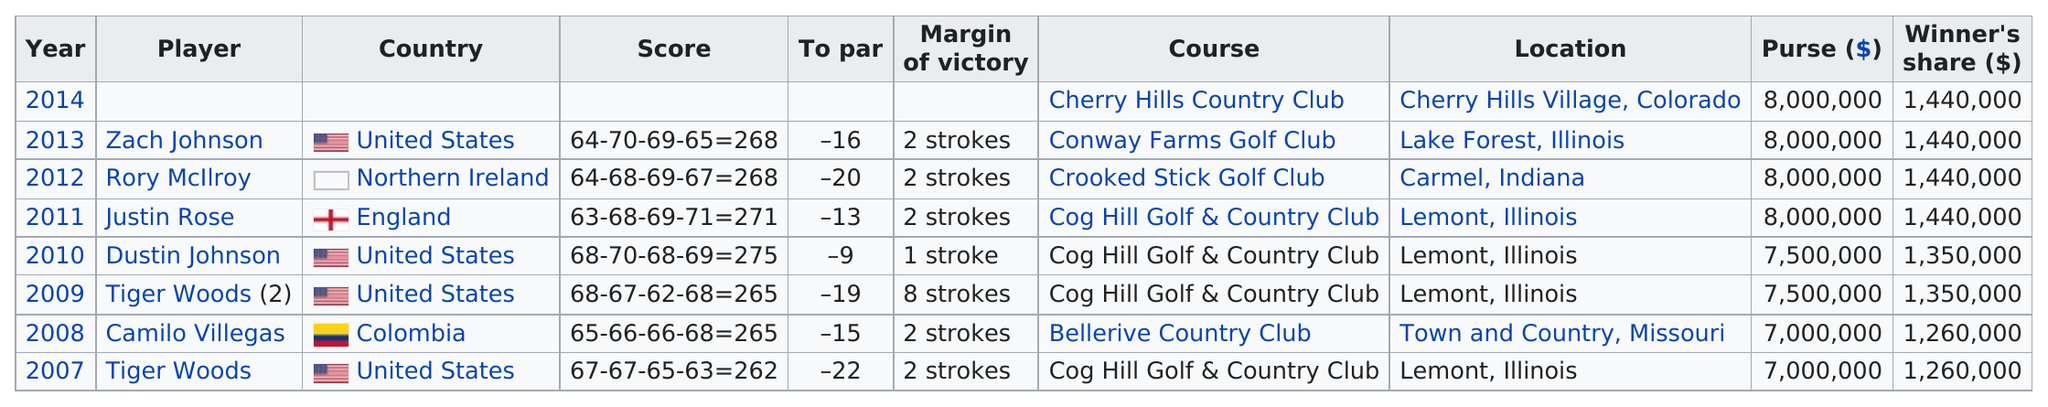Draw attention to some important aspects in this diagram. Tiger Woods earned the most between 2007 and 2013 in the Western Open. Justin Rose won the 2011 tournament with a margin of victory that was marked by two strokes. Since 2007, the total amount of American players who have won the Western Open is three. The first player to win with a score over 70 in a single round is Justin Rose. Following Justin Rose's victory in 2011, Rory McIlroy won the next tournament. 